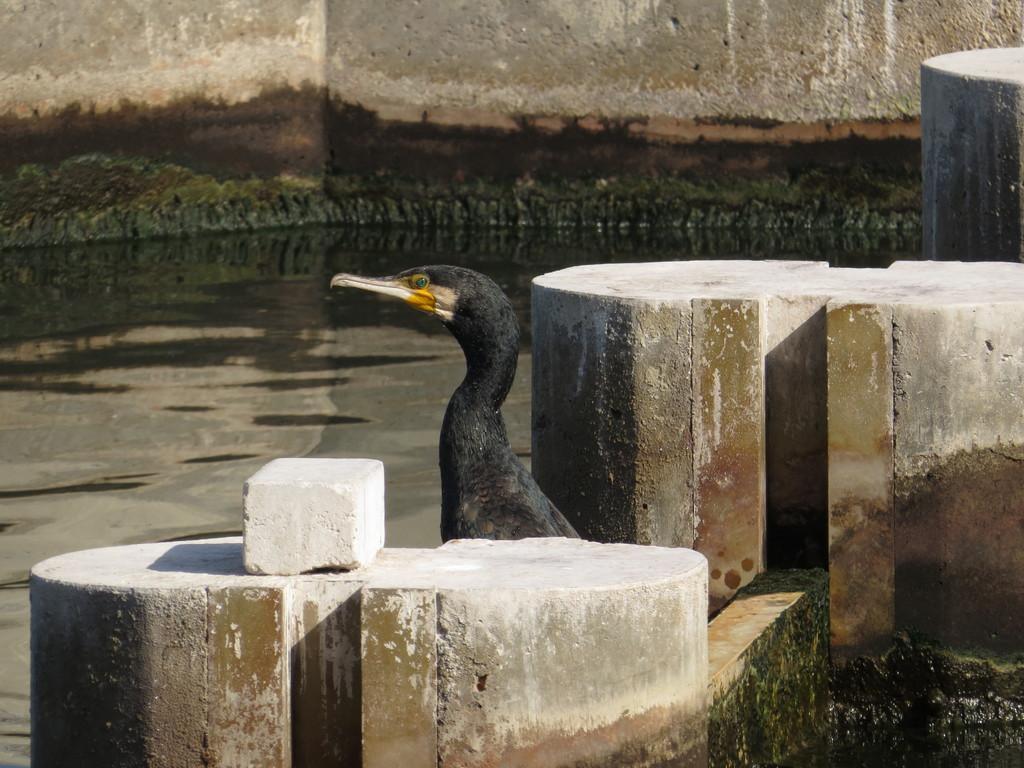Could you give a brief overview of what you see in this image? In this image I can see a bird which is in black,yellow color. I can see few cement benches,wall and water. 